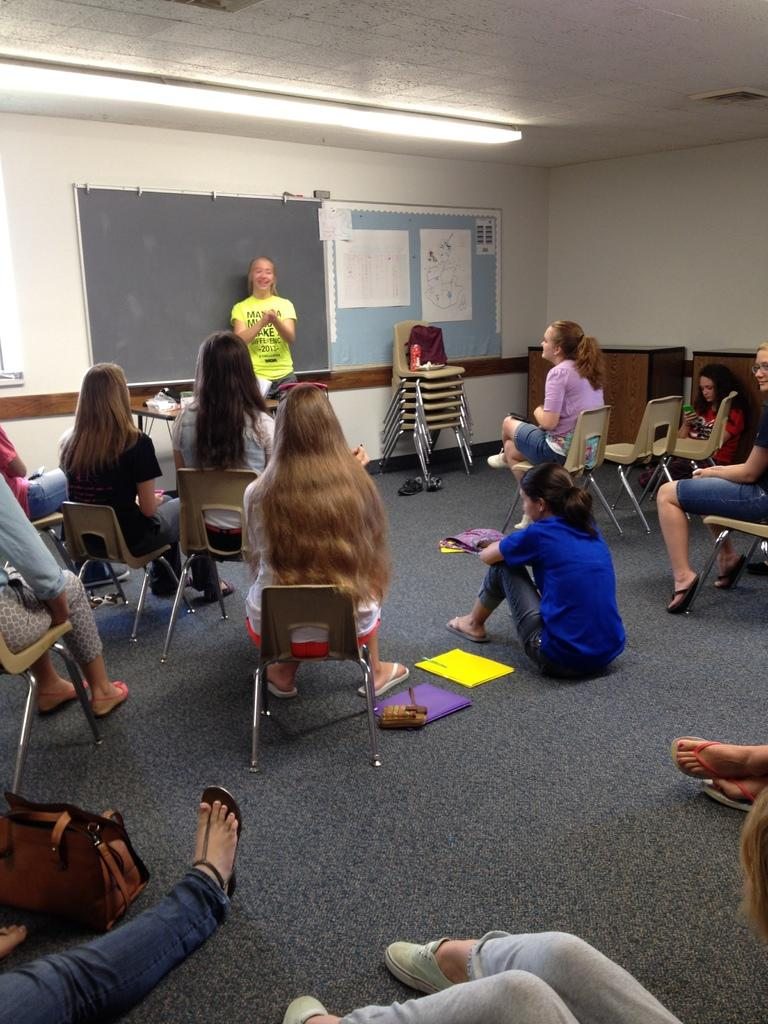What are the people in the image doing? The people in the image are sitting on chairs. Can you describe the girl in the image? There is a girl standing near a blackboard in the image. Where is the drain located in the image? There is no drain present in the image. What type of ship can be seen in the image? There is no ship present in the image. 